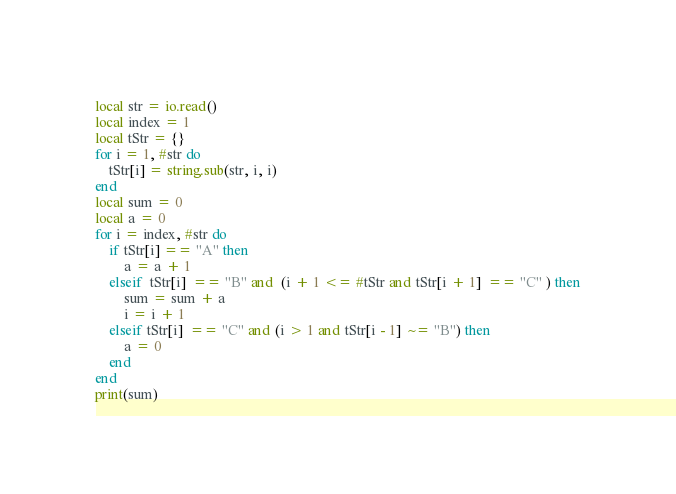<code> <loc_0><loc_0><loc_500><loc_500><_Lua_>local str = io.read()
local index = 1
local tStr = {}
for i = 1, #str do
    tStr[i] = string.sub(str, i, i)
end
local sum = 0
local a = 0
for i = index, #str do
    if tStr[i] == "A" then
        a = a + 1
    elseif  tStr[i]  == "B" and  (i + 1 <= #tStr and tStr[i + 1]  == "C" ) then
        sum = sum + a
        i = i + 1
    elseif tStr[i]  == "C" and (i > 1 and tStr[i - 1]  ~= "B") then
        a = 0
    end
end
print(sum)
</code> 